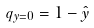<formula> <loc_0><loc_0><loc_500><loc_500>q _ { y = 0 } = 1 - \hat { y }</formula> 